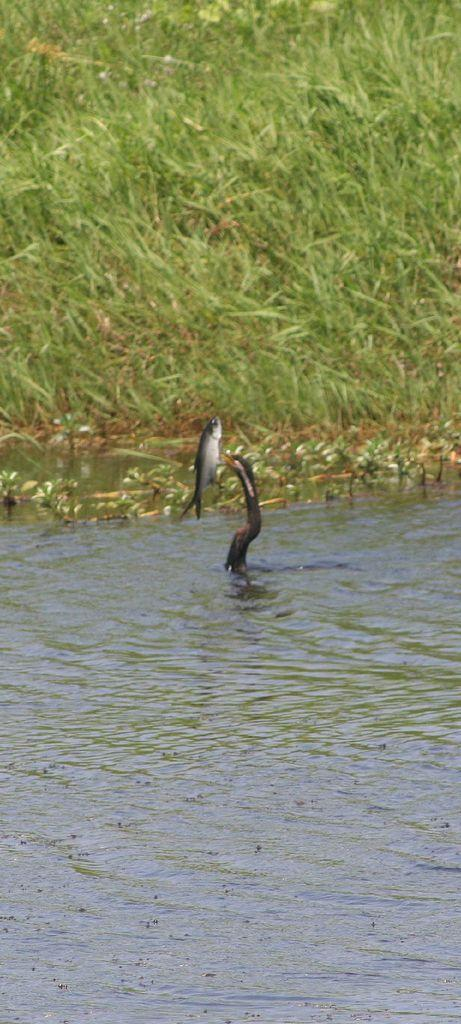What is visible in the image? Water is visible in the image. What type of animal can be seen in the image? There is a bird in the image. What is the bird doing in the image? The bird is catching fish. What type of vegetation is present on the ground in the image? The ground is covered with grass. What type of government is depicted in the image? There is no depiction of a government in the image; it features a bird catching fish in the water. How many eyes does the bird have in the image? The image does not show the bird's eyes, so it is not possible to determine the number of eyes the bird has. 